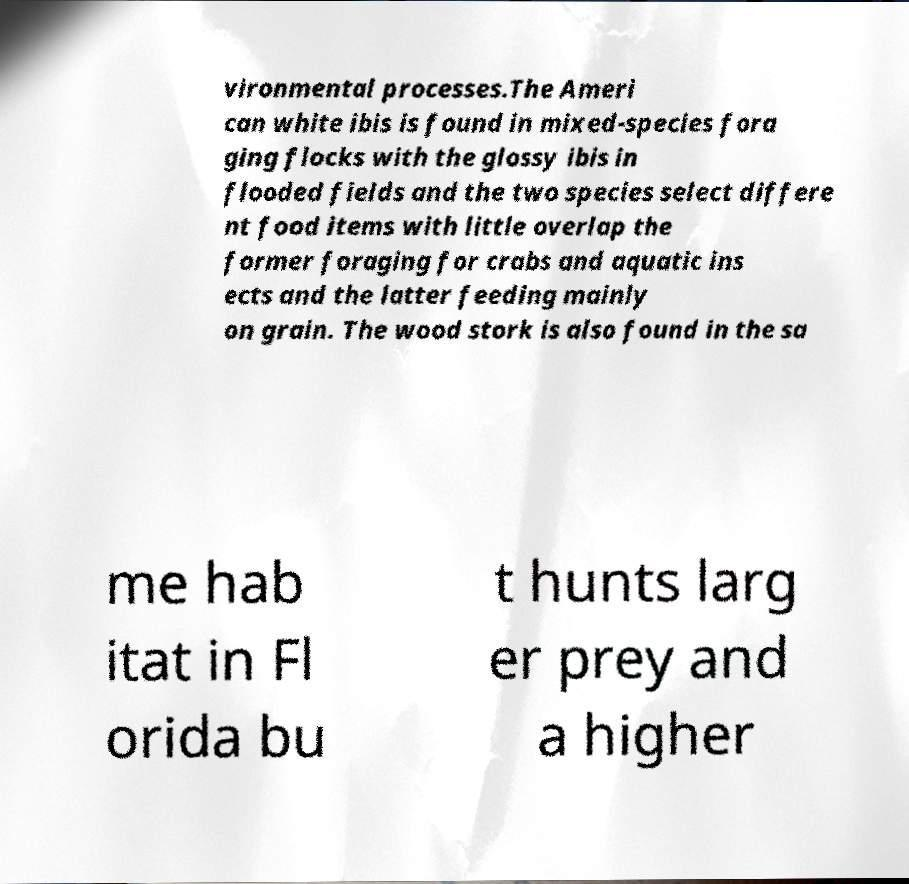Please read and relay the text visible in this image. What does it say? vironmental processes.The Ameri can white ibis is found in mixed-species fora ging flocks with the glossy ibis in flooded fields and the two species select differe nt food items with little overlap the former foraging for crabs and aquatic ins ects and the latter feeding mainly on grain. The wood stork is also found in the sa me hab itat in Fl orida bu t hunts larg er prey and a higher 